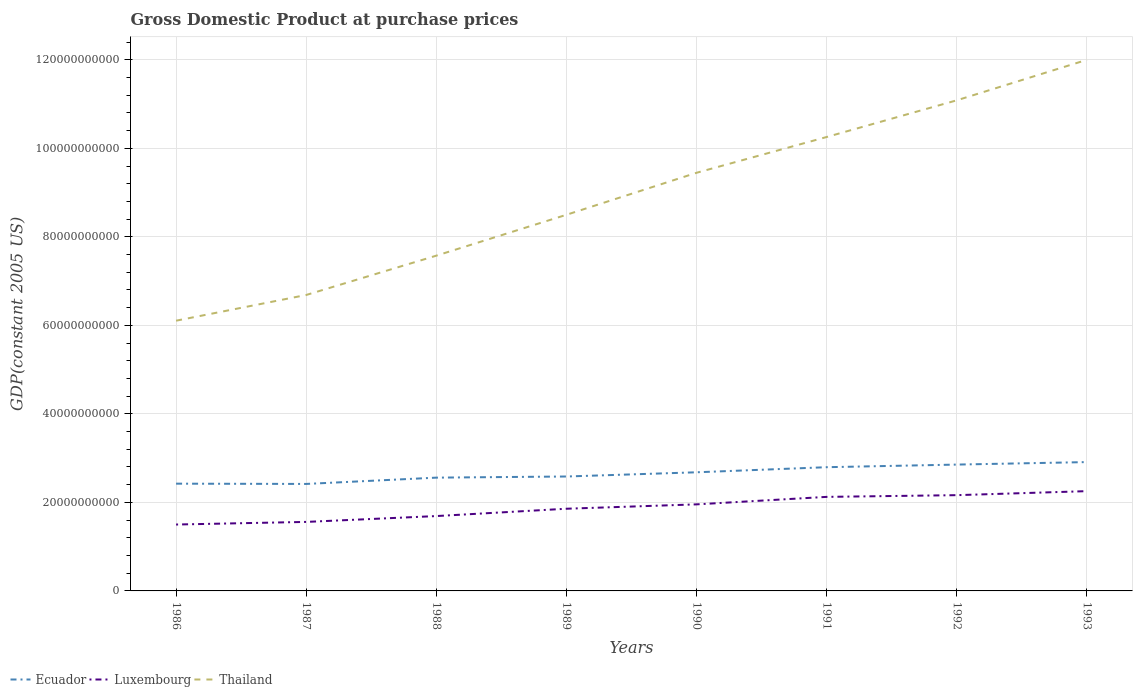Does the line corresponding to Luxembourg intersect with the line corresponding to Thailand?
Make the answer very short. No. Is the number of lines equal to the number of legend labels?
Ensure brevity in your answer.  Yes. Across all years, what is the maximum GDP at purchase prices in Thailand?
Make the answer very short. 6.11e+1. In which year was the GDP at purchase prices in Thailand maximum?
Keep it short and to the point. 1986. What is the total GDP at purchase prices in Thailand in the graph?
Your response must be concise. -1.76e+1. What is the difference between the highest and the second highest GDP at purchase prices in Ecuador?
Ensure brevity in your answer.  4.94e+09. Is the GDP at purchase prices in Ecuador strictly greater than the GDP at purchase prices in Luxembourg over the years?
Keep it short and to the point. No. How many years are there in the graph?
Your answer should be very brief. 8. Does the graph contain any zero values?
Offer a terse response. No. Where does the legend appear in the graph?
Ensure brevity in your answer.  Bottom left. How many legend labels are there?
Keep it short and to the point. 3. How are the legend labels stacked?
Ensure brevity in your answer.  Horizontal. What is the title of the graph?
Offer a terse response. Gross Domestic Product at purchase prices. What is the label or title of the X-axis?
Make the answer very short. Years. What is the label or title of the Y-axis?
Give a very brief answer. GDP(constant 2005 US). What is the GDP(constant 2005 US) of Ecuador in 1986?
Provide a succinct answer. 2.42e+1. What is the GDP(constant 2005 US) of Luxembourg in 1986?
Keep it short and to the point. 1.50e+1. What is the GDP(constant 2005 US) in Thailand in 1986?
Your answer should be compact. 6.11e+1. What is the GDP(constant 2005 US) in Ecuador in 1987?
Your response must be concise. 2.42e+1. What is the GDP(constant 2005 US) of Luxembourg in 1987?
Your answer should be very brief. 1.56e+1. What is the GDP(constant 2005 US) in Thailand in 1987?
Offer a very short reply. 6.69e+1. What is the GDP(constant 2005 US) of Ecuador in 1988?
Your answer should be very brief. 2.56e+1. What is the GDP(constant 2005 US) of Luxembourg in 1988?
Provide a succinct answer. 1.69e+1. What is the GDP(constant 2005 US) of Thailand in 1988?
Your answer should be very brief. 7.58e+1. What is the GDP(constant 2005 US) in Ecuador in 1989?
Your answer should be compact. 2.59e+1. What is the GDP(constant 2005 US) in Luxembourg in 1989?
Provide a succinct answer. 1.86e+1. What is the GDP(constant 2005 US) of Thailand in 1989?
Your answer should be very brief. 8.50e+1. What is the GDP(constant 2005 US) in Ecuador in 1990?
Offer a terse response. 2.68e+1. What is the GDP(constant 2005 US) of Luxembourg in 1990?
Provide a succinct answer. 1.96e+1. What is the GDP(constant 2005 US) of Thailand in 1990?
Your response must be concise. 9.45e+1. What is the GDP(constant 2005 US) of Ecuador in 1991?
Your answer should be very brief. 2.80e+1. What is the GDP(constant 2005 US) in Luxembourg in 1991?
Make the answer very short. 2.12e+1. What is the GDP(constant 2005 US) in Thailand in 1991?
Give a very brief answer. 1.03e+11. What is the GDP(constant 2005 US) of Ecuador in 1992?
Ensure brevity in your answer.  2.85e+1. What is the GDP(constant 2005 US) in Luxembourg in 1992?
Provide a succinct answer. 2.16e+1. What is the GDP(constant 2005 US) in Thailand in 1992?
Offer a very short reply. 1.11e+11. What is the GDP(constant 2005 US) in Ecuador in 1993?
Keep it short and to the point. 2.91e+1. What is the GDP(constant 2005 US) of Luxembourg in 1993?
Provide a succinct answer. 2.25e+1. What is the GDP(constant 2005 US) of Thailand in 1993?
Give a very brief answer. 1.20e+11. Across all years, what is the maximum GDP(constant 2005 US) of Ecuador?
Offer a very short reply. 2.91e+1. Across all years, what is the maximum GDP(constant 2005 US) of Luxembourg?
Provide a succinct answer. 2.25e+1. Across all years, what is the maximum GDP(constant 2005 US) in Thailand?
Keep it short and to the point. 1.20e+11. Across all years, what is the minimum GDP(constant 2005 US) of Ecuador?
Give a very brief answer. 2.42e+1. Across all years, what is the minimum GDP(constant 2005 US) in Luxembourg?
Keep it short and to the point. 1.50e+1. Across all years, what is the minimum GDP(constant 2005 US) in Thailand?
Provide a short and direct response. 6.11e+1. What is the total GDP(constant 2005 US) in Ecuador in the graph?
Make the answer very short. 2.12e+11. What is the total GDP(constant 2005 US) in Luxembourg in the graph?
Ensure brevity in your answer.  1.51e+11. What is the total GDP(constant 2005 US) in Thailand in the graph?
Ensure brevity in your answer.  7.17e+11. What is the difference between the GDP(constant 2005 US) in Ecuador in 1986 and that in 1987?
Provide a short and direct response. 6.28e+07. What is the difference between the GDP(constant 2005 US) in Luxembourg in 1986 and that in 1987?
Offer a very short reply. -5.93e+08. What is the difference between the GDP(constant 2005 US) of Thailand in 1986 and that in 1987?
Offer a very short reply. -5.81e+09. What is the difference between the GDP(constant 2005 US) in Ecuador in 1986 and that in 1988?
Your answer should be very brief. -1.36e+09. What is the difference between the GDP(constant 2005 US) of Luxembourg in 1986 and that in 1988?
Give a very brief answer. -1.91e+09. What is the difference between the GDP(constant 2005 US) of Thailand in 1986 and that in 1988?
Offer a terse response. -1.47e+1. What is the difference between the GDP(constant 2005 US) of Ecuador in 1986 and that in 1989?
Your answer should be compact. -1.62e+09. What is the difference between the GDP(constant 2005 US) of Luxembourg in 1986 and that in 1989?
Make the answer very short. -3.57e+09. What is the difference between the GDP(constant 2005 US) of Thailand in 1986 and that in 1989?
Give a very brief answer. -2.39e+1. What is the difference between the GDP(constant 2005 US) in Ecuador in 1986 and that in 1990?
Ensure brevity in your answer.  -2.57e+09. What is the difference between the GDP(constant 2005 US) of Luxembourg in 1986 and that in 1990?
Your response must be concise. -4.56e+09. What is the difference between the GDP(constant 2005 US) in Thailand in 1986 and that in 1990?
Give a very brief answer. -3.34e+1. What is the difference between the GDP(constant 2005 US) of Ecuador in 1986 and that in 1991?
Provide a succinct answer. -3.72e+09. What is the difference between the GDP(constant 2005 US) of Luxembourg in 1986 and that in 1991?
Your answer should be compact. -6.25e+09. What is the difference between the GDP(constant 2005 US) in Thailand in 1986 and that in 1991?
Your answer should be very brief. -4.15e+1. What is the difference between the GDP(constant 2005 US) of Ecuador in 1986 and that in 1992?
Provide a succinct answer. -4.31e+09. What is the difference between the GDP(constant 2005 US) in Luxembourg in 1986 and that in 1992?
Ensure brevity in your answer.  -6.63e+09. What is the difference between the GDP(constant 2005 US) of Thailand in 1986 and that in 1992?
Ensure brevity in your answer.  -4.98e+1. What is the difference between the GDP(constant 2005 US) in Ecuador in 1986 and that in 1993?
Your answer should be compact. -4.87e+09. What is the difference between the GDP(constant 2005 US) in Luxembourg in 1986 and that in 1993?
Keep it short and to the point. -7.54e+09. What is the difference between the GDP(constant 2005 US) of Thailand in 1986 and that in 1993?
Provide a succinct answer. -5.89e+1. What is the difference between the GDP(constant 2005 US) in Ecuador in 1987 and that in 1988?
Give a very brief answer. -1.42e+09. What is the difference between the GDP(constant 2005 US) of Luxembourg in 1987 and that in 1988?
Offer a terse response. -1.32e+09. What is the difference between the GDP(constant 2005 US) in Thailand in 1987 and that in 1988?
Offer a terse response. -8.89e+09. What is the difference between the GDP(constant 2005 US) of Ecuador in 1987 and that in 1989?
Your response must be concise. -1.68e+09. What is the difference between the GDP(constant 2005 US) in Luxembourg in 1987 and that in 1989?
Make the answer very short. -2.98e+09. What is the difference between the GDP(constant 2005 US) of Thailand in 1987 and that in 1989?
Offer a terse response. -1.81e+1. What is the difference between the GDP(constant 2005 US) in Ecuador in 1987 and that in 1990?
Ensure brevity in your answer.  -2.63e+09. What is the difference between the GDP(constant 2005 US) in Luxembourg in 1987 and that in 1990?
Your answer should be very brief. -3.96e+09. What is the difference between the GDP(constant 2005 US) in Thailand in 1987 and that in 1990?
Provide a short and direct response. -2.76e+1. What is the difference between the GDP(constant 2005 US) of Ecuador in 1987 and that in 1991?
Provide a short and direct response. -3.78e+09. What is the difference between the GDP(constant 2005 US) in Luxembourg in 1987 and that in 1991?
Offer a very short reply. -5.66e+09. What is the difference between the GDP(constant 2005 US) of Thailand in 1987 and that in 1991?
Make the answer very short. -3.57e+1. What is the difference between the GDP(constant 2005 US) of Ecuador in 1987 and that in 1992?
Provide a short and direct response. -4.37e+09. What is the difference between the GDP(constant 2005 US) in Luxembourg in 1987 and that in 1992?
Provide a succinct answer. -6.04e+09. What is the difference between the GDP(constant 2005 US) in Thailand in 1987 and that in 1992?
Offer a terse response. -4.40e+1. What is the difference between the GDP(constant 2005 US) in Ecuador in 1987 and that in 1993?
Your answer should be compact. -4.94e+09. What is the difference between the GDP(constant 2005 US) in Luxembourg in 1987 and that in 1993?
Offer a terse response. -6.95e+09. What is the difference between the GDP(constant 2005 US) in Thailand in 1987 and that in 1993?
Offer a very short reply. -5.31e+1. What is the difference between the GDP(constant 2005 US) of Ecuador in 1988 and that in 1989?
Your response must be concise. -2.57e+08. What is the difference between the GDP(constant 2005 US) in Luxembourg in 1988 and that in 1989?
Provide a succinct answer. -1.66e+09. What is the difference between the GDP(constant 2005 US) in Thailand in 1988 and that in 1989?
Ensure brevity in your answer.  -9.23e+09. What is the difference between the GDP(constant 2005 US) in Ecuador in 1988 and that in 1990?
Your response must be concise. -1.21e+09. What is the difference between the GDP(constant 2005 US) in Luxembourg in 1988 and that in 1990?
Provide a succinct answer. -2.65e+09. What is the difference between the GDP(constant 2005 US) of Thailand in 1988 and that in 1990?
Provide a succinct answer. -1.87e+1. What is the difference between the GDP(constant 2005 US) in Ecuador in 1988 and that in 1991?
Your response must be concise. -2.36e+09. What is the difference between the GDP(constant 2005 US) of Luxembourg in 1988 and that in 1991?
Make the answer very short. -4.34e+09. What is the difference between the GDP(constant 2005 US) in Thailand in 1988 and that in 1991?
Your answer should be compact. -2.68e+1. What is the difference between the GDP(constant 2005 US) of Ecuador in 1988 and that in 1992?
Offer a very short reply. -2.95e+09. What is the difference between the GDP(constant 2005 US) of Luxembourg in 1988 and that in 1992?
Offer a very short reply. -4.72e+09. What is the difference between the GDP(constant 2005 US) of Thailand in 1988 and that in 1992?
Offer a very short reply. -3.51e+1. What is the difference between the GDP(constant 2005 US) of Ecuador in 1988 and that in 1993?
Your response must be concise. -3.51e+09. What is the difference between the GDP(constant 2005 US) in Luxembourg in 1988 and that in 1993?
Provide a succinct answer. -5.63e+09. What is the difference between the GDP(constant 2005 US) of Thailand in 1988 and that in 1993?
Keep it short and to the point. -4.42e+1. What is the difference between the GDP(constant 2005 US) in Ecuador in 1989 and that in 1990?
Your answer should be compact. -9.51e+08. What is the difference between the GDP(constant 2005 US) of Luxembourg in 1989 and that in 1990?
Make the answer very short. -9.88e+08. What is the difference between the GDP(constant 2005 US) in Thailand in 1989 and that in 1990?
Your answer should be compact. -9.49e+09. What is the difference between the GDP(constant 2005 US) of Ecuador in 1989 and that in 1991?
Give a very brief answer. -2.10e+09. What is the difference between the GDP(constant 2005 US) in Luxembourg in 1989 and that in 1991?
Your answer should be very brief. -2.68e+09. What is the difference between the GDP(constant 2005 US) in Thailand in 1989 and that in 1991?
Offer a terse response. -1.76e+1. What is the difference between the GDP(constant 2005 US) in Ecuador in 1989 and that in 1992?
Offer a terse response. -2.69e+09. What is the difference between the GDP(constant 2005 US) in Luxembourg in 1989 and that in 1992?
Offer a terse response. -3.07e+09. What is the difference between the GDP(constant 2005 US) of Thailand in 1989 and that in 1992?
Keep it short and to the point. -2.59e+1. What is the difference between the GDP(constant 2005 US) in Ecuador in 1989 and that in 1993?
Provide a short and direct response. -3.26e+09. What is the difference between the GDP(constant 2005 US) of Luxembourg in 1989 and that in 1993?
Your answer should be compact. -3.97e+09. What is the difference between the GDP(constant 2005 US) in Thailand in 1989 and that in 1993?
Offer a very short reply. -3.50e+1. What is the difference between the GDP(constant 2005 US) in Ecuador in 1990 and that in 1991?
Provide a short and direct response. -1.15e+09. What is the difference between the GDP(constant 2005 US) of Luxembourg in 1990 and that in 1991?
Make the answer very short. -1.69e+09. What is the difference between the GDP(constant 2005 US) of Thailand in 1990 and that in 1991?
Your answer should be compact. -8.09e+09. What is the difference between the GDP(constant 2005 US) of Ecuador in 1990 and that in 1992?
Offer a terse response. -1.74e+09. What is the difference between the GDP(constant 2005 US) in Luxembourg in 1990 and that in 1992?
Your answer should be very brief. -2.08e+09. What is the difference between the GDP(constant 2005 US) of Thailand in 1990 and that in 1992?
Provide a succinct answer. -1.64e+1. What is the difference between the GDP(constant 2005 US) in Ecuador in 1990 and that in 1993?
Offer a very short reply. -2.30e+09. What is the difference between the GDP(constant 2005 US) in Luxembourg in 1990 and that in 1993?
Keep it short and to the point. -2.99e+09. What is the difference between the GDP(constant 2005 US) in Thailand in 1990 and that in 1993?
Make the answer very short. -2.55e+1. What is the difference between the GDP(constant 2005 US) of Ecuador in 1991 and that in 1992?
Ensure brevity in your answer.  -5.91e+08. What is the difference between the GDP(constant 2005 US) of Luxembourg in 1991 and that in 1992?
Ensure brevity in your answer.  -3.87e+08. What is the difference between the GDP(constant 2005 US) in Thailand in 1991 and that in 1992?
Provide a short and direct response. -8.29e+09. What is the difference between the GDP(constant 2005 US) in Ecuador in 1991 and that in 1993?
Give a very brief answer. -1.15e+09. What is the difference between the GDP(constant 2005 US) in Luxembourg in 1991 and that in 1993?
Make the answer very short. -1.30e+09. What is the difference between the GDP(constant 2005 US) of Thailand in 1991 and that in 1993?
Ensure brevity in your answer.  -1.74e+1. What is the difference between the GDP(constant 2005 US) in Ecuador in 1992 and that in 1993?
Make the answer very short. -5.63e+08. What is the difference between the GDP(constant 2005 US) in Luxembourg in 1992 and that in 1993?
Keep it short and to the point. -9.09e+08. What is the difference between the GDP(constant 2005 US) of Thailand in 1992 and that in 1993?
Keep it short and to the point. -9.15e+09. What is the difference between the GDP(constant 2005 US) of Ecuador in 1986 and the GDP(constant 2005 US) of Luxembourg in 1987?
Ensure brevity in your answer.  8.64e+09. What is the difference between the GDP(constant 2005 US) of Ecuador in 1986 and the GDP(constant 2005 US) of Thailand in 1987?
Offer a very short reply. -4.26e+1. What is the difference between the GDP(constant 2005 US) of Luxembourg in 1986 and the GDP(constant 2005 US) of Thailand in 1987?
Keep it short and to the point. -5.19e+1. What is the difference between the GDP(constant 2005 US) of Ecuador in 1986 and the GDP(constant 2005 US) of Luxembourg in 1988?
Offer a very short reply. 7.32e+09. What is the difference between the GDP(constant 2005 US) in Ecuador in 1986 and the GDP(constant 2005 US) in Thailand in 1988?
Provide a succinct answer. -5.15e+1. What is the difference between the GDP(constant 2005 US) in Luxembourg in 1986 and the GDP(constant 2005 US) in Thailand in 1988?
Your answer should be compact. -6.08e+1. What is the difference between the GDP(constant 2005 US) in Ecuador in 1986 and the GDP(constant 2005 US) in Luxembourg in 1989?
Give a very brief answer. 5.66e+09. What is the difference between the GDP(constant 2005 US) of Ecuador in 1986 and the GDP(constant 2005 US) of Thailand in 1989?
Your response must be concise. -6.08e+1. What is the difference between the GDP(constant 2005 US) of Luxembourg in 1986 and the GDP(constant 2005 US) of Thailand in 1989?
Your response must be concise. -7.00e+1. What is the difference between the GDP(constant 2005 US) of Ecuador in 1986 and the GDP(constant 2005 US) of Luxembourg in 1990?
Your answer should be compact. 4.68e+09. What is the difference between the GDP(constant 2005 US) in Ecuador in 1986 and the GDP(constant 2005 US) in Thailand in 1990?
Give a very brief answer. -7.02e+1. What is the difference between the GDP(constant 2005 US) of Luxembourg in 1986 and the GDP(constant 2005 US) of Thailand in 1990?
Provide a short and direct response. -7.95e+1. What is the difference between the GDP(constant 2005 US) of Ecuador in 1986 and the GDP(constant 2005 US) of Luxembourg in 1991?
Provide a succinct answer. 2.98e+09. What is the difference between the GDP(constant 2005 US) in Ecuador in 1986 and the GDP(constant 2005 US) in Thailand in 1991?
Provide a succinct answer. -7.83e+1. What is the difference between the GDP(constant 2005 US) of Luxembourg in 1986 and the GDP(constant 2005 US) of Thailand in 1991?
Provide a short and direct response. -8.76e+1. What is the difference between the GDP(constant 2005 US) of Ecuador in 1986 and the GDP(constant 2005 US) of Luxembourg in 1992?
Offer a terse response. 2.60e+09. What is the difference between the GDP(constant 2005 US) of Ecuador in 1986 and the GDP(constant 2005 US) of Thailand in 1992?
Your answer should be very brief. -8.66e+1. What is the difference between the GDP(constant 2005 US) in Luxembourg in 1986 and the GDP(constant 2005 US) in Thailand in 1992?
Offer a very short reply. -9.59e+1. What is the difference between the GDP(constant 2005 US) in Ecuador in 1986 and the GDP(constant 2005 US) in Luxembourg in 1993?
Provide a succinct answer. 1.69e+09. What is the difference between the GDP(constant 2005 US) in Ecuador in 1986 and the GDP(constant 2005 US) in Thailand in 1993?
Offer a very short reply. -9.58e+1. What is the difference between the GDP(constant 2005 US) in Luxembourg in 1986 and the GDP(constant 2005 US) in Thailand in 1993?
Make the answer very short. -1.05e+11. What is the difference between the GDP(constant 2005 US) of Ecuador in 1987 and the GDP(constant 2005 US) of Luxembourg in 1988?
Make the answer very short. 7.26e+09. What is the difference between the GDP(constant 2005 US) of Ecuador in 1987 and the GDP(constant 2005 US) of Thailand in 1988?
Provide a short and direct response. -5.16e+1. What is the difference between the GDP(constant 2005 US) in Luxembourg in 1987 and the GDP(constant 2005 US) in Thailand in 1988?
Your answer should be very brief. -6.02e+1. What is the difference between the GDP(constant 2005 US) of Ecuador in 1987 and the GDP(constant 2005 US) of Luxembourg in 1989?
Your answer should be very brief. 5.60e+09. What is the difference between the GDP(constant 2005 US) of Ecuador in 1987 and the GDP(constant 2005 US) of Thailand in 1989?
Offer a terse response. -6.08e+1. What is the difference between the GDP(constant 2005 US) in Luxembourg in 1987 and the GDP(constant 2005 US) in Thailand in 1989?
Provide a short and direct response. -6.94e+1. What is the difference between the GDP(constant 2005 US) in Ecuador in 1987 and the GDP(constant 2005 US) in Luxembourg in 1990?
Provide a short and direct response. 4.61e+09. What is the difference between the GDP(constant 2005 US) in Ecuador in 1987 and the GDP(constant 2005 US) in Thailand in 1990?
Provide a succinct answer. -7.03e+1. What is the difference between the GDP(constant 2005 US) in Luxembourg in 1987 and the GDP(constant 2005 US) in Thailand in 1990?
Your response must be concise. -7.89e+1. What is the difference between the GDP(constant 2005 US) of Ecuador in 1987 and the GDP(constant 2005 US) of Luxembourg in 1991?
Your response must be concise. 2.92e+09. What is the difference between the GDP(constant 2005 US) of Ecuador in 1987 and the GDP(constant 2005 US) of Thailand in 1991?
Give a very brief answer. -7.84e+1. What is the difference between the GDP(constant 2005 US) in Luxembourg in 1987 and the GDP(constant 2005 US) in Thailand in 1991?
Your answer should be very brief. -8.70e+1. What is the difference between the GDP(constant 2005 US) of Ecuador in 1987 and the GDP(constant 2005 US) of Luxembourg in 1992?
Provide a short and direct response. 2.54e+09. What is the difference between the GDP(constant 2005 US) of Ecuador in 1987 and the GDP(constant 2005 US) of Thailand in 1992?
Provide a short and direct response. -8.67e+1. What is the difference between the GDP(constant 2005 US) in Luxembourg in 1987 and the GDP(constant 2005 US) in Thailand in 1992?
Make the answer very short. -9.53e+1. What is the difference between the GDP(constant 2005 US) of Ecuador in 1987 and the GDP(constant 2005 US) of Luxembourg in 1993?
Your response must be concise. 1.63e+09. What is the difference between the GDP(constant 2005 US) of Ecuador in 1987 and the GDP(constant 2005 US) of Thailand in 1993?
Keep it short and to the point. -9.58e+1. What is the difference between the GDP(constant 2005 US) in Luxembourg in 1987 and the GDP(constant 2005 US) in Thailand in 1993?
Your answer should be compact. -1.04e+11. What is the difference between the GDP(constant 2005 US) of Ecuador in 1988 and the GDP(constant 2005 US) of Luxembourg in 1989?
Provide a succinct answer. 7.02e+09. What is the difference between the GDP(constant 2005 US) in Ecuador in 1988 and the GDP(constant 2005 US) in Thailand in 1989?
Ensure brevity in your answer.  -5.94e+1. What is the difference between the GDP(constant 2005 US) of Luxembourg in 1988 and the GDP(constant 2005 US) of Thailand in 1989?
Ensure brevity in your answer.  -6.81e+1. What is the difference between the GDP(constant 2005 US) in Ecuador in 1988 and the GDP(constant 2005 US) in Luxembourg in 1990?
Your response must be concise. 6.04e+09. What is the difference between the GDP(constant 2005 US) of Ecuador in 1988 and the GDP(constant 2005 US) of Thailand in 1990?
Offer a terse response. -6.89e+1. What is the difference between the GDP(constant 2005 US) of Luxembourg in 1988 and the GDP(constant 2005 US) of Thailand in 1990?
Give a very brief answer. -7.76e+1. What is the difference between the GDP(constant 2005 US) of Ecuador in 1988 and the GDP(constant 2005 US) of Luxembourg in 1991?
Your answer should be compact. 4.35e+09. What is the difference between the GDP(constant 2005 US) of Ecuador in 1988 and the GDP(constant 2005 US) of Thailand in 1991?
Provide a succinct answer. -7.70e+1. What is the difference between the GDP(constant 2005 US) in Luxembourg in 1988 and the GDP(constant 2005 US) in Thailand in 1991?
Make the answer very short. -8.56e+1. What is the difference between the GDP(constant 2005 US) of Ecuador in 1988 and the GDP(constant 2005 US) of Luxembourg in 1992?
Ensure brevity in your answer.  3.96e+09. What is the difference between the GDP(constant 2005 US) in Ecuador in 1988 and the GDP(constant 2005 US) in Thailand in 1992?
Your response must be concise. -8.53e+1. What is the difference between the GDP(constant 2005 US) in Luxembourg in 1988 and the GDP(constant 2005 US) in Thailand in 1992?
Your response must be concise. -9.39e+1. What is the difference between the GDP(constant 2005 US) in Ecuador in 1988 and the GDP(constant 2005 US) in Luxembourg in 1993?
Provide a succinct answer. 3.05e+09. What is the difference between the GDP(constant 2005 US) in Ecuador in 1988 and the GDP(constant 2005 US) in Thailand in 1993?
Make the answer very short. -9.44e+1. What is the difference between the GDP(constant 2005 US) in Luxembourg in 1988 and the GDP(constant 2005 US) in Thailand in 1993?
Offer a very short reply. -1.03e+11. What is the difference between the GDP(constant 2005 US) in Ecuador in 1989 and the GDP(constant 2005 US) in Luxembourg in 1990?
Offer a very short reply. 6.29e+09. What is the difference between the GDP(constant 2005 US) of Ecuador in 1989 and the GDP(constant 2005 US) of Thailand in 1990?
Offer a very short reply. -6.86e+1. What is the difference between the GDP(constant 2005 US) of Luxembourg in 1989 and the GDP(constant 2005 US) of Thailand in 1990?
Your response must be concise. -7.59e+1. What is the difference between the GDP(constant 2005 US) in Ecuador in 1989 and the GDP(constant 2005 US) in Luxembourg in 1991?
Your response must be concise. 4.60e+09. What is the difference between the GDP(constant 2005 US) of Ecuador in 1989 and the GDP(constant 2005 US) of Thailand in 1991?
Give a very brief answer. -7.67e+1. What is the difference between the GDP(constant 2005 US) of Luxembourg in 1989 and the GDP(constant 2005 US) of Thailand in 1991?
Provide a short and direct response. -8.40e+1. What is the difference between the GDP(constant 2005 US) of Ecuador in 1989 and the GDP(constant 2005 US) of Luxembourg in 1992?
Your answer should be very brief. 4.22e+09. What is the difference between the GDP(constant 2005 US) in Ecuador in 1989 and the GDP(constant 2005 US) in Thailand in 1992?
Provide a short and direct response. -8.50e+1. What is the difference between the GDP(constant 2005 US) of Luxembourg in 1989 and the GDP(constant 2005 US) of Thailand in 1992?
Make the answer very short. -9.23e+1. What is the difference between the GDP(constant 2005 US) in Ecuador in 1989 and the GDP(constant 2005 US) in Luxembourg in 1993?
Provide a succinct answer. 3.31e+09. What is the difference between the GDP(constant 2005 US) in Ecuador in 1989 and the GDP(constant 2005 US) in Thailand in 1993?
Your response must be concise. -9.41e+1. What is the difference between the GDP(constant 2005 US) of Luxembourg in 1989 and the GDP(constant 2005 US) of Thailand in 1993?
Your response must be concise. -1.01e+11. What is the difference between the GDP(constant 2005 US) in Ecuador in 1990 and the GDP(constant 2005 US) in Luxembourg in 1991?
Provide a short and direct response. 5.55e+09. What is the difference between the GDP(constant 2005 US) in Ecuador in 1990 and the GDP(constant 2005 US) in Thailand in 1991?
Keep it short and to the point. -7.58e+1. What is the difference between the GDP(constant 2005 US) in Luxembourg in 1990 and the GDP(constant 2005 US) in Thailand in 1991?
Ensure brevity in your answer.  -8.30e+1. What is the difference between the GDP(constant 2005 US) in Ecuador in 1990 and the GDP(constant 2005 US) in Luxembourg in 1992?
Keep it short and to the point. 5.17e+09. What is the difference between the GDP(constant 2005 US) of Ecuador in 1990 and the GDP(constant 2005 US) of Thailand in 1992?
Offer a very short reply. -8.40e+1. What is the difference between the GDP(constant 2005 US) in Luxembourg in 1990 and the GDP(constant 2005 US) in Thailand in 1992?
Ensure brevity in your answer.  -9.13e+1. What is the difference between the GDP(constant 2005 US) in Ecuador in 1990 and the GDP(constant 2005 US) in Luxembourg in 1993?
Offer a terse response. 4.26e+09. What is the difference between the GDP(constant 2005 US) of Ecuador in 1990 and the GDP(constant 2005 US) of Thailand in 1993?
Offer a terse response. -9.32e+1. What is the difference between the GDP(constant 2005 US) of Luxembourg in 1990 and the GDP(constant 2005 US) of Thailand in 1993?
Keep it short and to the point. -1.00e+11. What is the difference between the GDP(constant 2005 US) of Ecuador in 1991 and the GDP(constant 2005 US) of Luxembourg in 1992?
Provide a short and direct response. 6.32e+09. What is the difference between the GDP(constant 2005 US) in Ecuador in 1991 and the GDP(constant 2005 US) in Thailand in 1992?
Your answer should be compact. -8.29e+1. What is the difference between the GDP(constant 2005 US) in Luxembourg in 1991 and the GDP(constant 2005 US) in Thailand in 1992?
Your response must be concise. -8.96e+1. What is the difference between the GDP(constant 2005 US) in Ecuador in 1991 and the GDP(constant 2005 US) in Luxembourg in 1993?
Offer a terse response. 5.41e+09. What is the difference between the GDP(constant 2005 US) in Ecuador in 1991 and the GDP(constant 2005 US) in Thailand in 1993?
Make the answer very short. -9.20e+1. What is the difference between the GDP(constant 2005 US) of Luxembourg in 1991 and the GDP(constant 2005 US) of Thailand in 1993?
Provide a short and direct response. -9.88e+1. What is the difference between the GDP(constant 2005 US) of Ecuador in 1992 and the GDP(constant 2005 US) of Luxembourg in 1993?
Offer a very short reply. 6.00e+09. What is the difference between the GDP(constant 2005 US) of Ecuador in 1992 and the GDP(constant 2005 US) of Thailand in 1993?
Your response must be concise. -9.15e+1. What is the difference between the GDP(constant 2005 US) in Luxembourg in 1992 and the GDP(constant 2005 US) in Thailand in 1993?
Make the answer very short. -9.84e+1. What is the average GDP(constant 2005 US) in Ecuador per year?
Your answer should be compact. 2.65e+1. What is the average GDP(constant 2005 US) of Luxembourg per year?
Your answer should be very brief. 1.89e+1. What is the average GDP(constant 2005 US) in Thailand per year?
Your response must be concise. 8.96e+1. In the year 1986, what is the difference between the GDP(constant 2005 US) of Ecuador and GDP(constant 2005 US) of Luxembourg?
Keep it short and to the point. 9.23e+09. In the year 1986, what is the difference between the GDP(constant 2005 US) of Ecuador and GDP(constant 2005 US) of Thailand?
Give a very brief answer. -3.68e+1. In the year 1986, what is the difference between the GDP(constant 2005 US) of Luxembourg and GDP(constant 2005 US) of Thailand?
Make the answer very short. -4.61e+1. In the year 1987, what is the difference between the GDP(constant 2005 US) in Ecuador and GDP(constant 2005 US) in Luxembourg?
Give a very brief answer. 8.58e+09. In the year 1987, what is the difference between the GDP(constant 2005 US) of Ecuador and GDP(constant 2005 US) of Thailand?
Your answer should be compact. -4.27e+1. In the year 1987, what is the difference between the GDP(constant 2005 US) of Luxembourg and GDP(constant 2005 US) of Thailand?
Provide a short and direct response. -5.13e+1. In the year 1988, what is the difference between the GDP(constant 2005 US) in Ecuador and GDP(constant 2005 US) in Luxembourg?
Offer a terse response. 8.68e+09. In the year 1988, what is the difference between the GDP(constant 2005 US) of Ecuador and GDP(constant 2005 US) of Thailand?
Ensure brevity in your answer.  -5.02e+1. In the year 1988, what is the difference between the GDP(constant 2005 US) in Luxembourg and GDP(constant 2005 US) in Thailand?
Provide a short and direct response. -5.88e+1. In the year 1989, what is the difference between the GDP(constant 2005 US) in Ecuador and GDP(constant 2005 US) in Luxembourg?
Offer a very short reply. 7.28e+09. In the year 1989, what is the difference between the GDP(constant 2005 US) in Ecuador and GDP(constant 2005 US) in Thailand?
Ensure brevity in your answer.  -5.91e+1. In the year 1989, what is the difference between the GDP(constant 2005 US) in Luxembourg and GDP(constant 2005 US) in Thailand?
Keep it short and to the point. -6.64e+1. In the year 1990, what is the difference between the GDP(constant 2005 US) in Ecuador and GDP(constant 2005 US) in Luxembourg?
Ensure brevity in your answer.  7.25e+09. In the year 1990, what is the difference between the GDP(constant 2005 US) of Ecuador and GDP(constant 2005 US) of Thailand?
Your answer should be very brief. -6.77e+1. In the year 1990, what is the difference between the GDP(constant 2005 US) in Luxembourg and GDP(constant 2005 US) in Thailand?
Offer a terse response. -7.49e+1. In the year 1991, what is the difference between the GDP(constant 2005 US) in Ecuador and GDP(constant 2005 US) in Luxembourg?
Give a very brief answer. 6.71e+09. In the year 1991, what is the difference between the GDP(constant 2005 US) in Ecuador and GDP(constant 2005 US) in Thailand?
Your answer should be very brief. -7.46e+1. In the year 1991, what is the difference between the GDP(constant 2005 US) of Luxembourg and GDP(constant 2005 US) of Thailand?
Provide a succinct answer. -8.13e+1. In the year 1992, what is the difference between the GDP(constant 2005 US) of Ecuador and GDP(constant 2005 US) of Luxembourg?
Offer a very short reply. 6.91e+09. In the year 1992, what is the difference between the GDP(constant 2005 US) of Ecuador and GDP(constant 2005 US) of Thailand?
Your response must be concise. -8.23e+1. In the year 1992, what is the difference between the GDP(constant 2005 US) of Luxembourg and GDP(constant 2005 US) of Thailand?
Offer a terse response. -8.92e+1. In the year 1993, what is the difference between the GDP(constant 2005 US) of Ecuador and GDP(constant 2005 US) of Luxembourg?
Your answer should be very brief. 6.56e+09. In the year 1993, what is the difference between the GDP(constant 2005 US) in Ecuador and GDP(constant 2005 US) in Thailand?
Give a very brief answer. -9.09e+1. In the year 1993, what is the difference between the GDP(constant 2005 US) in Luxembourg and GDP(constant 2005 US) in Thailand?
Ensure brevity in your answer.  -9.75e+1. What is the ratio of the GDP(constant 2005 US) in Luxembourg in 1986 to that in 1987?
Provide a short and direct response. 0.96. What is the ratio of the GDP(constant 2005 US) of Thailand in 1986 to that in 1987?
Make the answer very short. 0.91. What is the ratio of the GDP(constant 2005 US) in Ecuador in 1986 to that in 1988?
Provide a short and direct response. 0.95. What is the ratio of the GDP(constant 2005 US) of Luxembourg in 1986 to that in 1988?
Make the answer very short. 0.89. What is the ratio of the GDP(constant 2005 US) in Thailand in 1986 to that in 1988?
Give a very brief answer. 0.81. What is the ratio of the GDP(constant 2005 US) in Ecuador in 1986 to that in 1989?
Provide a short and direct response. 0.94. What is the ratio of the GDP(constant 2005 US) in Luxembourg in 1986 to that in 1989?
Ensure brevity in your answer.  0.81. What is the ratio of the GDP(constant 2005 US) in Thailand in 1986 to that in 1989?
Keep it short and to the point. 0.72. What is the ratio of the GDP(constant 2005 US) in Ecuador in 1986 to that in 1990?
Your answer should be very brief. 0.9. What is the ratio of the GDP(constant 2005 US) in Luxembourg in 1986 to that in 1990?
Provide a short and direct response. 0.77. What is the ratio of the GDP(constant 2005 US) in Thailand in 1986 to that in 1990?
Your answer should be compact. 0.65. What is the ratio of the GDP(constant 2005 US) of Ecuador in 1986 to that in 1991?
Your answer should be compact. 0.87. What is the ratio of the GDP(constant 2005 US) of Luxembourg in 1986 to that in 1991?
Your answer should be compact. 0.71. What is the ratio of the GDP(constant 2005 US) of Thailand in 1986 to that in 1991?
Offer a very short reply. 0.6. What is the ratio of the GDP(constant 2005 US) of Ecuador in 1986 to that in 1992?
Your answer should be very brief. 0.85. What is the ratio of the GDP(constant 2005 US) in Luxembourg in 1986 to that in 1992?
Keep it short and to the point. 0.69. What is the ratio of the GDP(constant 2005 US) in Thailand in 1986 to that in 1992?
Offer a very short reply. 0.55. What is the ratio of the GDP(constant 2005 US) of Ecuador in 1986 to that in 1993?
Provide a short and direct response. 0.83. What is the ratio of the GDP(constant 2005 US) in Luxembourg in 1986 to that in 1993?
Provide a short and direct response. 0.67. What is the ratio of the GDP(constant 2005 US) of Thailand in 1986 to that in 1993?
Make the answer very short. 0.51. What is the ratio of the GDP(constant 2005 US) of Ecuador in 1987 to that in 1988?
Your response must be concise. 0.94. What is the ratio of the GDP(constant 2005 US) in Luxembourg in 1987 to that in 1988?
Keep it short and to the point. 0.92. What is the ratio of the GDP(constant 2005 US) of Thailand in 1987 to that in 1988?
Offer a very short reply. 0.88. What is the ratio of the GDP(constant 2005 US) of Ecuador in 1987 to that in 1989?
Keep it short and to the point. 0.94. What is the ratio of the GDP(constant 2005 US) of Luxembourg in 1987 to that in 1989?
Provide a short and direct response. 0.84. What is the ratio of the GDP(constant 2005 US) in Thailand in 1987 to that in 1989?
Keep it short and to the point. 0.79. What is the ratio of the GDP(constant 2005 US) of Ecuador in 1987 to that in 1990?
Offer a terse response. 0.9. What is the ratio of the GDP(constant 2005 US) in Luxembourg in 1987 to that in 1990?
Provide a short and direct response. 0.8. What is the ratio of the GDP(constant 2005 US) in Thailand in 1987 to that in 1990?
Ensure brevity in your answer.  0.71. What is the ratio of the GDP(constant 2005 US) of Ecuador in 1987 to that in 1991?
Offer a very short reply. 0.86. What is the ratio of the GDP(constant 2005 US) in Luxembourg in 1987 to that in 1991?
Provide a short and direct response. 0.73. What is the ratio of the GDP(constant 2005 US) of Thailand in 1987 to that in 1991?
Keep it short and to the point. 0.65. What is the ratio of the GDP(constant 2005 US) of Ecuador in 1987 to that in 1992?
Provide a succinct answer. 0.85. What is the ratio of the GDP(constant 2005 US) of Luxembourg in 1987 to that in 1992?
Offer a very short reply. 0.72. What is the ratio of the GDP(constant 2005 US) of Thailand in 1987 to that in 1992?
Your answer should be very brief. 0.6. What is the ratio of the GDP(constant 2005 US) of Ecuador in 1987 to that in 1993?
Offer a terse response. 0.83. What is the ratio of the GDP(constant 2005 US) in Luxembourg in 1987 to that in 1993?
Your answer should be very brief. 0.69. What is the ratio of the GDP(constant 2005 US) in Thailand in 1987 to that in 1993?
Ensure brevity in your answer.  0.56. What is the ratio of the GDP(constant 2005 US) of Luxembourg in 1988 to that in 1989?
Give a very brief answer. 0.91. What is the ratio of the GDP(constant 2005 US) in Thailand in 1988 to that in 1989?
Offer a very short reply. 0.89. What is the ratio of the GDP(constant 2005 US) in Ecuador in 1988 to that in 1990?
Provide a succinct answer. 0.95. What is the ratio of the GDP(constant 2005 US) in Luxembourg in 1988 to that in 1990?
Provide a succinct answer. 0.86. What is the ratio of the GDP(constant 2005 US) of Thailand in 1988 to that in 1990?
Keep it short and to the point. 0.8. What is the ratio of the GDP(constant 2005 US) in Ecuador in 1988 to that in 1991?
Ensure brevity in your answer.  0.92. What is the ratio of the GDP(constant 2005 US) of Luxembourg in 1988 to that in 1991?
Offer a terse response. 0.8. What is the ratio of the GDP(constant 2005 US) in Thailand in 1988 to that in 1991?
Offer a very short reply. 0.74. What is the ratio of the GDP(constant 2005 US) of Ecuador in 1988 to that in 1992?
Keep it short and to the point. 0.9. What is the ratio of the GDP(constant 2005 US) of Luxembourg in 1988 to that in 1992?
Give a very brief answer. 0.78. What is the ratio of the GDP(constant 2005 US) in Thailand in 1988 to that in 1992?
Your answer should be compact. 0.68. What is the ratio of the GDP(constant 2005 US) of Ecuador in 1988 to that in 1993?
Your answer should be very brief. 0.88. What is the ratio of the GDP(constant 2005 US) of Luxembourg in 1988 to that in 1993?
Give a very brief answer. 0.75. What is the ratio of the GDP(constant 2005 US) in Thailand in 1988 to that in 1993?
Provide a short and direct response. 0.63. What is the ratio of the GDP(constant 2005 US) of Ecuador in 1989 to that in 1990?
Keep it short and to the point. 0.96. What is the ratio of the GDP(constant 2005 US) in Luxembourg in 1989 to that in 1990?
Provide a succinct answer. 0.95. What is the ratio of the GDP(constant 2005 US) in Thailand in 1989 to that in 1990?
Keep it short and to the point. 0.9. What is the ratio of the GDP(constant 2005 US) of Ecuador in 1989 to that in 1991?
Your response must be concise. 0.92. What is the ratio of the GDP(constant 2005 US) of Luxembourg in 1989 to that in 1991?
Your answer should be very brief. 0.87. What is the ratio of the GDP(constant 2005 US) in Thailand in 1989 to that in 1991?
Keep it short and to the point. 0.83. What is the ratio of the GDP(constant 2005 US) of Ecuador in 1989 to that in 1992?
Your answer should be very brief. 0.91. What is the ratio of the GDP(constant 2005 US) in Luxembourg in 1989 to that in 1992?
Offer a very short reply. 0.86. What is the ratio of the GDP(constant 2005 US) in Thailand in 1989 to that in 1992?
Offer a terse response. 0.77. What is the ratio of the GDP(constant 2005 US) in Ecuador in 1989 to that in 1993?
Your answer should be very brief. 0.89. What is the ratio of the GDP(constant 2005 US) in Luxembourg in 1989 to that in 1993?
Your response must be concise. 0.82. What is the ratio of the GDP(constant 2005 US) of Thailand in 1989 to that in 1993?
Offer a terse response. 0.71. What is the ratio of the GDP(constant 2005 US) of Ecuador in 1990 to that in 1991?
Provide a succinct answer. 0.96. What is the ratio of the GDP(constant 2005 US) in Luxembourg in 1990 to that in 1991?
Give a very brief answer. 0.92. What is the ratio of the GDP(constant 2005 US) in Thailand in 1990 to that in 1991?
Make the answer very short. 0.92. What is the ratio of the GDP(constant 2005 US) of Ecuador in 1990 to that in 1992?
Ensure brevity in your answer.  0.94. What is the ratio of the GDP(constant 2005 US) in Luxembourg in 1990 to that in 1992?
Your answer should be very brief. 0.9. What is the ratio of the GDP(constant 2005 US) of Thailand in 1990 to that in 1992?
Your answer should be compact. 0.85. What is the ratio of the GDP(constant 2005 US) in Ecuador in 1990 to that in 1993?
Offer a terse response. 0.92. What is the ratio of the GDP(constant 2005 US) in Luxembourg in 1990 to that in 1993?
Ensure brevity in your answer.  0.87. What is the ratio of the GDP(constant 2005 US) of Thailand in 1990 to that in 1993?
Your answer should be very brief. 0.79. What is the ratio of the GDP(constant 2005 US) of Ecuador in 1991 to that in 1992?
Your answer should be very brief. 0.98. What is the ratio of the GDP(constant 2005 US) in Luxembourg in 1991 to that in 1992?
Your response must be concise. 0.98. What is the ratio of the GDP(constant 2005 US) in Thailand in 1991 to that in 1992?
Your answer should be very brief. 0.93. What is the ratio of the GDP(constant 2005 US) of Ecuador in 1991 to that in 1993?
Offer a very short reply. 0.96. What is the ratio of the GDP(constant 2005 US) in Luxembourg in 1991 to that in 1993?
Keep it short and to the point. 0.94. What is the ratio of the GDP(constant 2005 US) of Thailand in 1991 to that in 1993?
Offer a very short reply. 0.85. What is the ratio of the GDP(constant 2005 US) in Ecuador in 1992 to that in 1993?
Your answer should be compact. 0.98. What is the ratio of the GDP(constant 2005 US) of Luxembourg in 1992 to that in 1993?
Your response must be concise. 0.96. What is the ratio of the GDP(constant 2005 US) in Thailand in 1992 to that in 1993?
Provide a succinct answer. 0.92. What is the difference between the highest and the second highest GDP(constant 2005 US) of Ecuador?
Your answer should be compact. 5.63e+08. What is the difference between the highest and the second highest GDP(constant 2005 US) of Luxembourg?
Offer a very short reply. 9.09e+08. What is the difference between the highest and the second highest GDP(constant 2005 US) in Thailand?
Give a very brief answer. 9.15e+09. What is the difference between the highest and the lowest GDP(constant 2005 US) of Ecuador?
Provide a short and direct response. 4.94e+09. What is the difference between the highest and the lowest GDP(constant 2005 US) of Luxembourg?
Your answer should be compact. 7.54e+09. What is the difference between the highest and the lowest GDP(constant 2005 US) in Thailand?
Your answer should be very brief. 5.89e+1. 